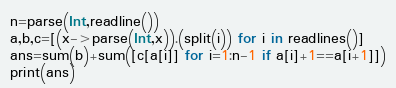<code> <loc_0><loc_0><loc_500><loc_500><_Julia_>n=parse(Int,readline())
a,b,c=[(x->parse(Int,x)).(split(i)) for i in readlines()]
ans=sum(b)+sum([c[a[i]] for i=1:n-1 if a[i]+1==a[i+1]])
print(ans)</code> 